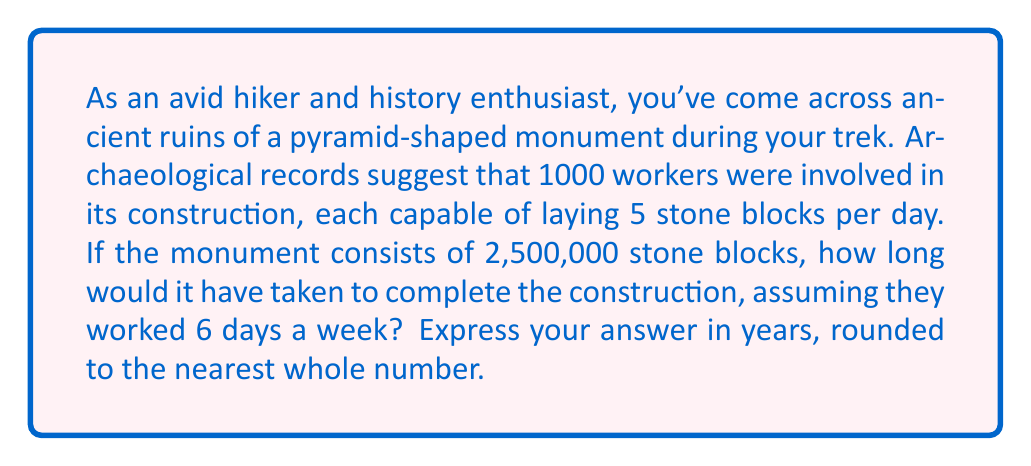Give your solution to this math problem. Let's approach this problem step-by-step:

1) First, calculate the total number of blocks that can be laid in one day:
   $$ \text{Blocks per day} = 1000 \text{ workers} \times 5 \text{ blocks per worker} = 5000 \text{ blocks} $$

2) Calculate the number of days needed to lay all blocks:
   $$ \text{Days needed} = \frac{2,500,000 \text{ blocks}}{5000 \text{ blocks per day}} = 500 \text{ days} $$

3) Convert working days to calendar days, considering they work 6 out of 7 days:
   $$ \text{Calendar days} = 500 \text{ working days} \times \frac{7}{6} = 583.33 \text{ days} $$

4) Convert days to years:
   $$ \text{Years} = \frac{583.33 \text{ days}}{365 \text{ days per year}} \approx 1.598 \text{ years} $$

5) Rounding to the nearest whole number:
   $$ 1.598 \text{ years} \approx 2 \text{ years} $$
Answer: 2 years 